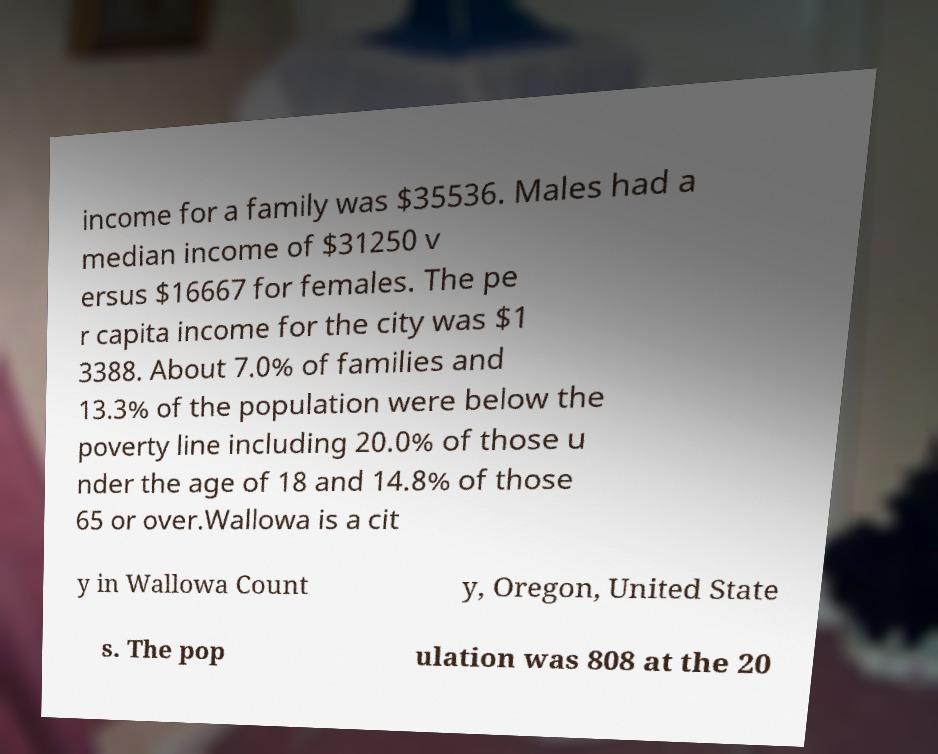Please read and relay the text visible in this image. What does it say? income for a family was $35536. Males had a median income of $31250 v ersus $16667 for females. The pe r capita income for the city was $1 3388. About 7.0% of families and 13.3% of the population were below the poverty line including 20.0% of those u nder the age of 18 and 14.8% of those 65 or over.Wallowa is a cit y in Wallowa Count y, Oregon, United State s. The pop ulation was 808 at the 20 